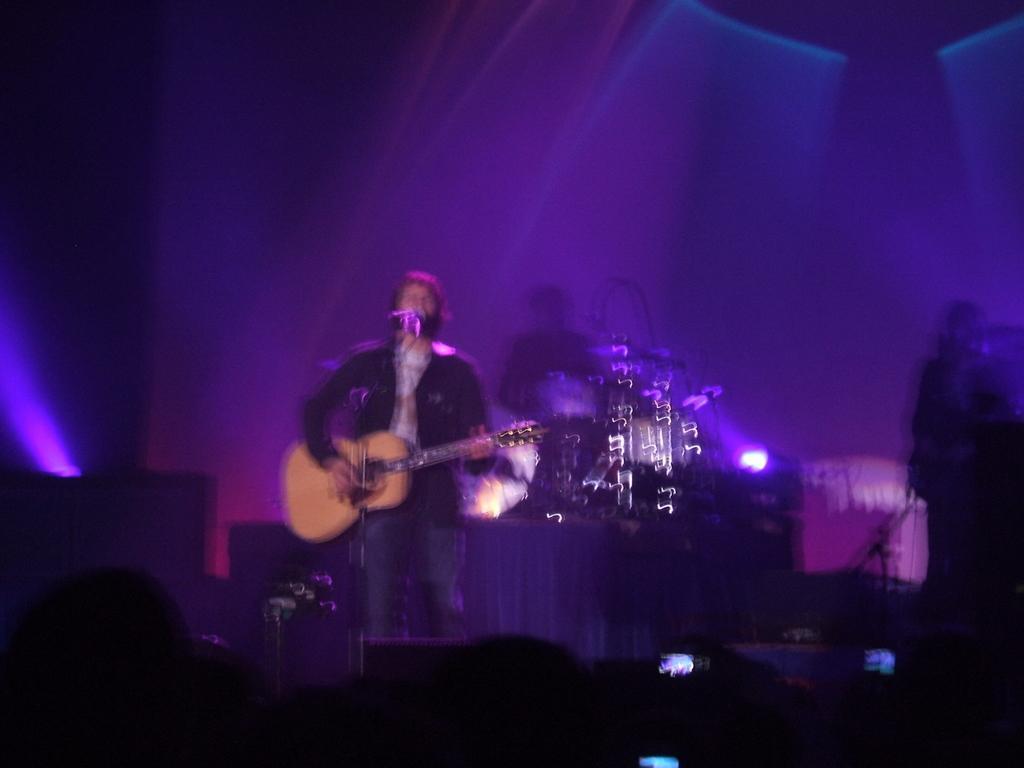Describe this image in one or two sentences. This picture shows a man standing on the stage, playing a guitar in his hands in front of a microphone. In the background there is another man sitting and playing drums here. There are some lights. 